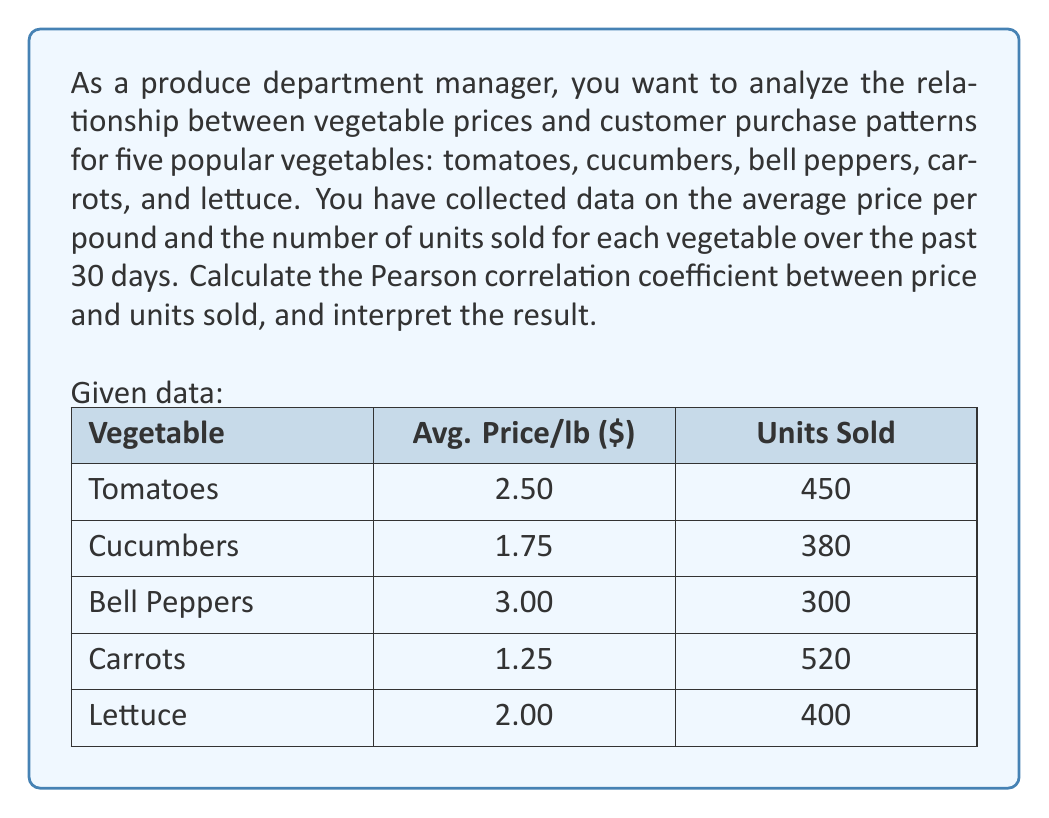Provide a solution to this math problem. To calculate the Pearson correlation coefficient between price and units sold, we'll follow these steps:

1. Calculate the means of price ($\bar{x}$) and units sold ($\bar{y}$):

   $\bar{x} = \frac{2.50 + 1.75 + 3.00 + 1.25 + 2.00}{5} = 2.10$
   $\bar{y} = \frac{450 + 380 + 300 + 520 + 400}{5} = 410$

2. Calculate the deviations from the means:

   Vegetable | $x - \bar{x}$ | $y - \bar{y}$
   Tomatoes  | 0.40          | 40
   Cucumbers | -0.35         | -30
   Bell Peppers | 0.90       | -110
   Carrots   | -0.85         | 110
   Lettuce   | -0.10         | -10

3. Calculate the products of deviations and their sum:

   $\sum(x - \bar{x})(y - \bar{y}) = (0.40 \times 40) + (-0.35 \times -30) + (0.90 \times -110) + (-0.85 \times 110) + (-0.10 \times -10) = -101.5$

4. Calculate the squared deviations and their sums:

   $\sum(x - \bar{x})^2 = 0.40^2 + (-0.35)^2 + 0.90^2 + (-0.85)^2 + (-0.10)^2 = 1.805$
   $\sum(y - \bar{y})^2 = 40^2 + (-30)^2 + (-110)^2 + 110^2 + (-10)^2 = 36,200$

5. Apply the Pearson correlation coefficient formula:

   $$r = \frac{\sum(x - \bar{x})(y - \bar{y})}{\sqrt{\sum(x - \bar{x})^2 \sum(y - \bar{y})^2}}$$

   $$r = \frac{-101.5}{\sqrt{1.805 \times 36,200}} = \frac{-101.5}{255.78} \approx -0.3968$$

6. Interpret the result:
   The correlation coefficient of -0.3968 indicates a moderate negative correlation between vegetable prices and units sold. This suggests that as prices increase, the number of units sold tends to decrease, and vice versa. However, the correlation is not very strong, implying that other factors may also influence customer purchase patterns.
Answer: The Pearson correlation coefficient between vegetable prices and units sold is approximately -0.3968, indicating a moderate negative correlation between price and customer purchase patterns. 